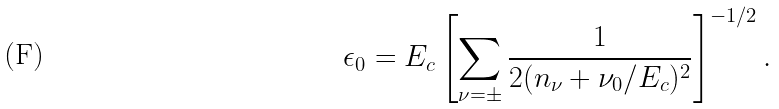Convert formula to latex. <formula><loc_0><loc_0><loc_500><loc_500>\epsilon _ { 0 } = E _ { c } \left [ \sum _ { \nu = \pm } \frac { 1 } { 2 ( n _ { \nu } + \nu _ { 0 } / E _ { c } ) ^ { 2 } } \right ] ^ { - 1 / 2 } .</formula> 